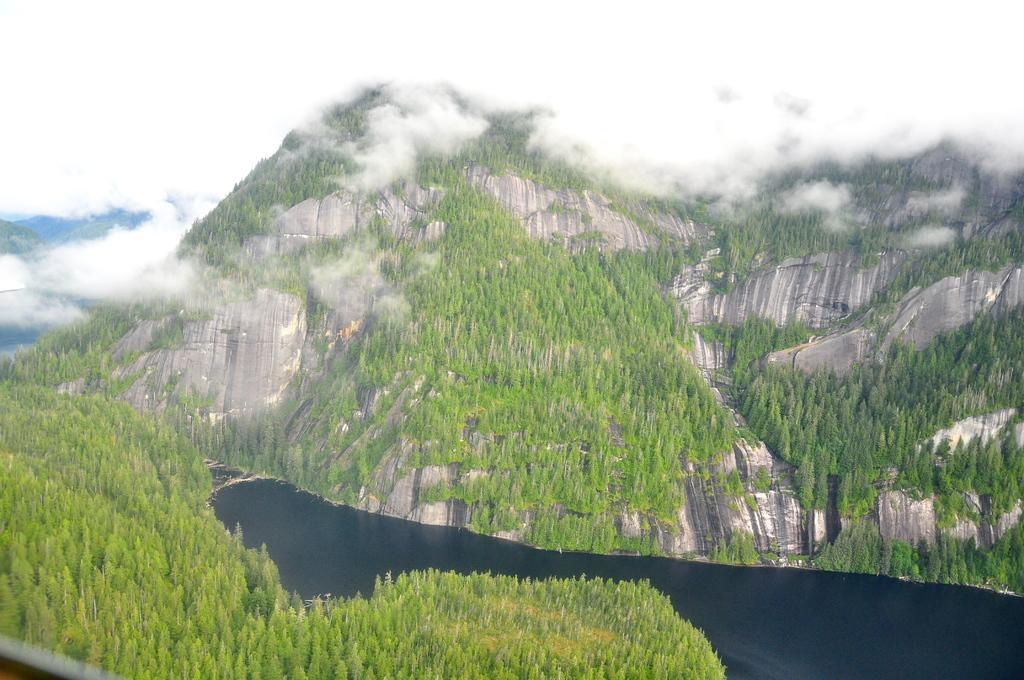What type of geographical feature is present in the image? There are hills in the image. What is covering the hills in the image? The hills are covered with trees. What atmospheric condition is visible in the image? There is fog in the image. What body of water is present in the image? There is a river in the center of the image. Where are the rocks located in the image? There are no rocks mentioned or visible in the image. How many bears can be seen playing near the river in the image? There are no bears present or visible in the image. 